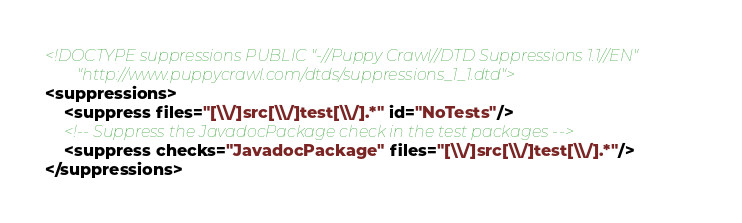<code> <loc_0><loc_0><loc_500><loc_500><_XML_><!DOCTYPE suppressions PUBLIC "-//Puppy Crawl//DTD Suppressions 1.1//EN"
        "http://www.puppycrawl.com/dtds/suppressions_1_1.dtd">
<suppressions>
    <suppress files="[\\/]src[\\/]test[\\/].*" id="NoTests"/>
    <!-- Suppress the JavadocPackage check in the test packages -->
    <suppress checks="JavadocPackage" files="[\\/]src[\\/]test[\\/].*"/>
</suppressions></code> 